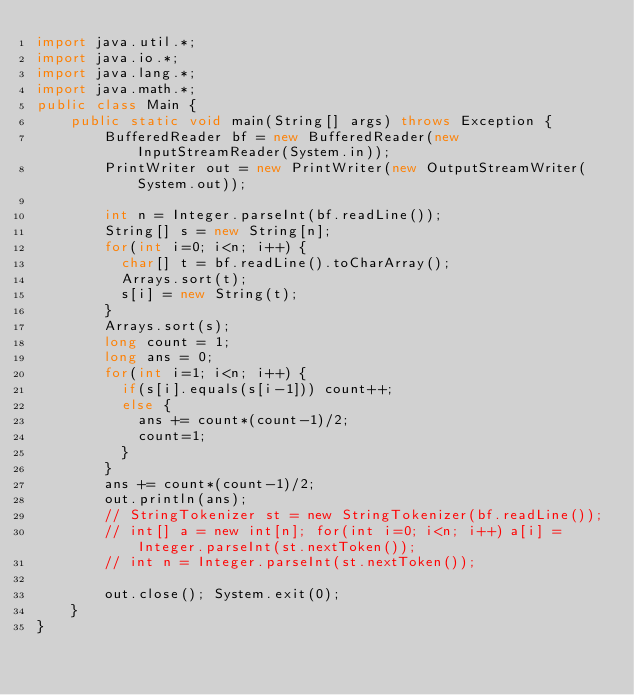Convert code to text. <code><loc_0><loc_0><loc_500><loc_500><_Java_>import java.util.*;
import java.io.*;
import java.lang.*;
import java.math.*;
public class Main {
    public static void main(String[] args) throws Exception {
        BufferedReader bf = new BufferedReader(new InputStreamReader(System.in));
        PrintWriter out = new PrintWriter(new OutputStreamWriter(System.out));

        int n = Integer.parseInt(bf.readLine());
        String[] s = new String[n];
        for(int i=0; i<n; i++) {
          char[] t = bf.readLine().toCharArray();
          Arrays.sort(t);
          s[i] = new String(t);
        }
        Arrays.sort(s);
        long count = 1;
        long ans = 0;
        for(int i=1; i<n; i++) {
          if(s[i].equals(s[i-1])) count++;
          else {
            ans += count*(count-1)/2;
            count=1;
          }
        }
        ans += count*(count-1)/2;
        out.println(ans);
        // StringTokenizer st = new StringTokenizer(bf.readLine());
        // int[] a = new int[n]; for(int i=0; i<n; i++) a[i] = Integer.parseInt(st.nextToken());
        // int n = Integer.parseInt(st.nextToken());

        out.close(); System.exit(0);
    }
}
</code> 